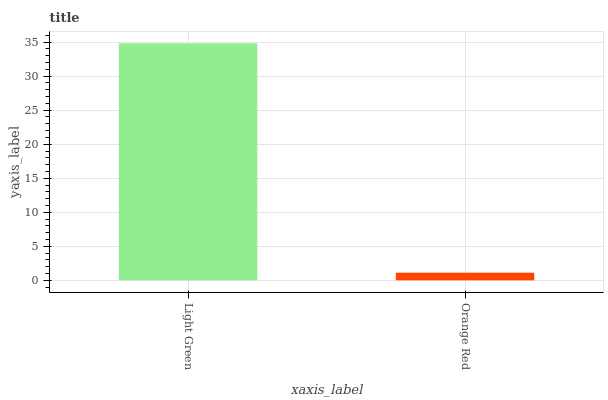Is Orange Red the minimum?
Answer yes or no. Yes. Is Light Green the maximum?
Answer yes or no. Yes. Is Orange Red the maximum?
Answer yes or no. No. Is Light Green greater than Orange Red?
Answer yes or no. Yes. Is Orange Red less than Light Green?
Answer yes or no. Yes. Is Orange Red greater than Light Green?
Answer yes or no. No. Is Light Green less than Orange Red?
Answer yes or no. No. Is Light Green the high median?
Answer yes or no. Yes. Is Orange Red the low median?
Answer yes or no. Yes. Is Orange Red the high median?
Answer yes or no. No. Is Light Green the low median?
Answer yes or no. No. 